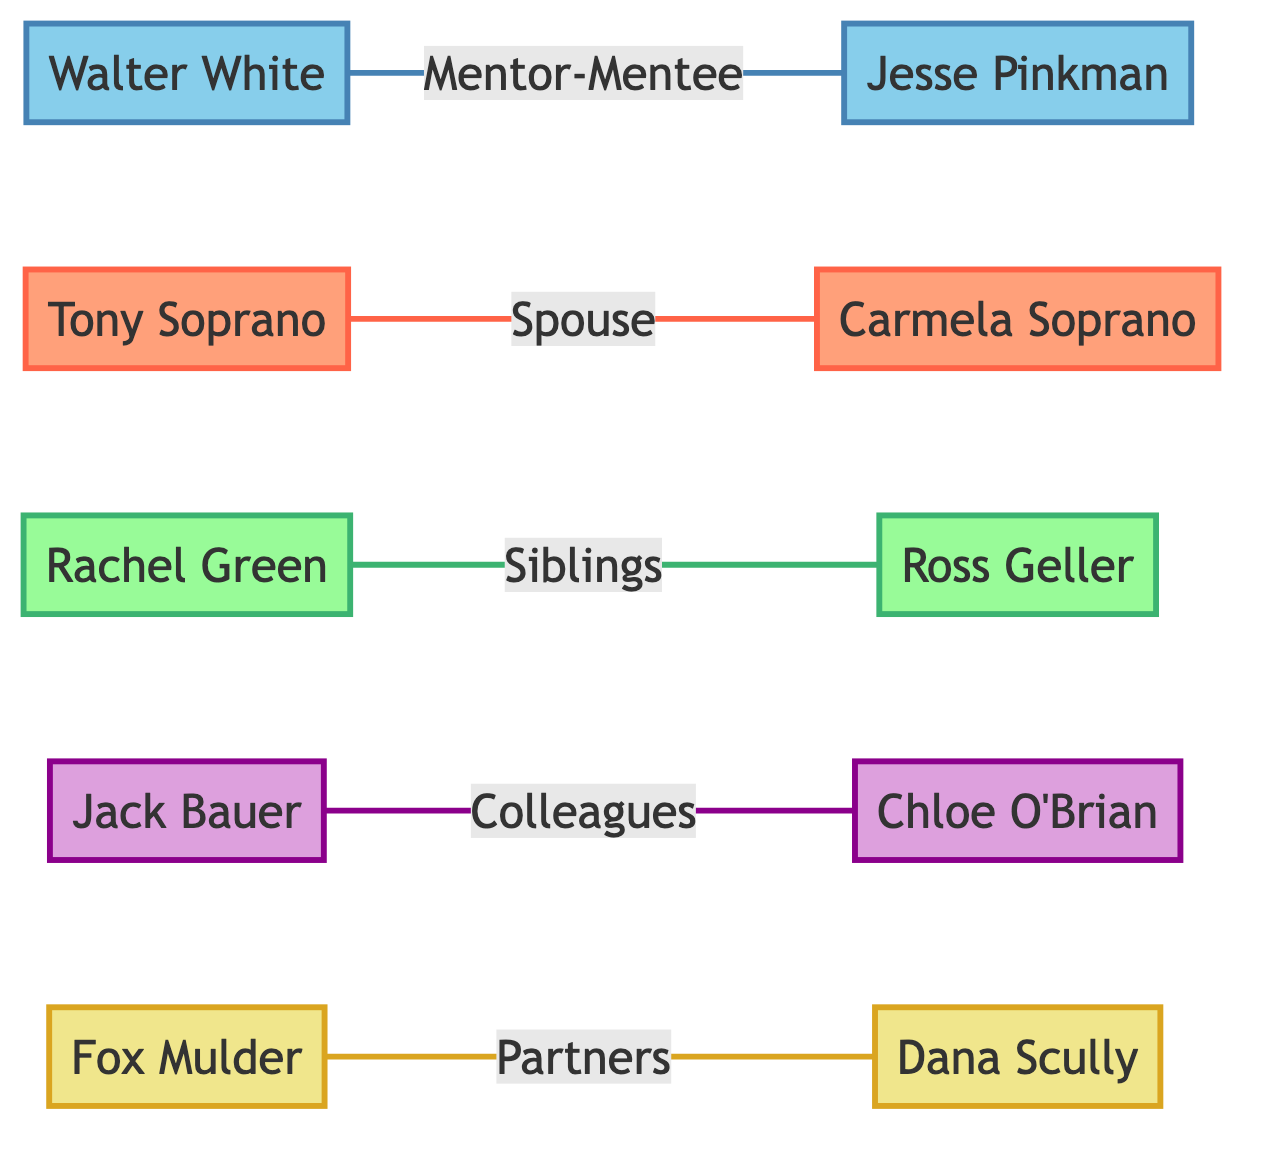What is the relationship between Walter White and Jesse Pinkman? In the diagram, there is a direct line connecting Walter White and Jesse Pinkman labeled "Mentor-Mentee," indicating that their relationship is defined as one where Walter White is a mentor to Jesse Pinkman.
Answer: Mentor-Mentee How many nodes are present in the diagram? The nodes in the diagram represent the key cast members, which total 10 when counted. Each character name in the diagram corresponds to a node.
Answer: 10 Which two characters are connected by the relationship labeled "Colleagues"? By examining the connections in the diagram, the line labeled "Colleagues" connects Jack Bauer and Chloe O'Brian, indicating their professional relationship within their respective show.
Answer: Jack Bauer and Chloe O'Brian What color represents the characters from the show "Friends"? In the diagram, characters from "Friends" are represented by the color green as specified in the "classDef friends" section, where the fill color is light green and the stroke is a darker green.
Answer: Green Which two cast members share a relationship defined as "Partners"? The diagram shows that Fox Mulder and Dana Scully are connected by a line labeled "Partners," indicating their cooperative relationship on their series.
Answer: Fox Mulder and Dana Scully How many types of relationships are depicted in the diagram? The diagram visually displays five types of relationships connecting various pairs of characters, each labeled differently: Mentor-Mentee, Spouse, Siblings, Colleagues, and Partners.
Answer: 5 Which character is directly linked to Carmela Soprano, and what type of relationship do they share? The diagram shows Carmela Soprano is connected to Tony Soprano, and the relationship is labeled as "Spouse." This indicates they are married to each other within the context of their show.
Answer: Tony Soprano, Spouse What is the primary focus of the diagram? The primary focus of this social network analysis diagram is to illustrate the relationships and interactions between key cast members in various iconic TV shows, showcasing their connections visually.
Answer: Relationships and interactions Which character has a mentor-mentee connection and is associated with the color blue? In the diagram, Walter White is the character with a mentor-mentee connection to Jesse Pinkman, and he is represented using shades of blue, according to the defined class for "Breaking Bad."
Answer: Walter White 